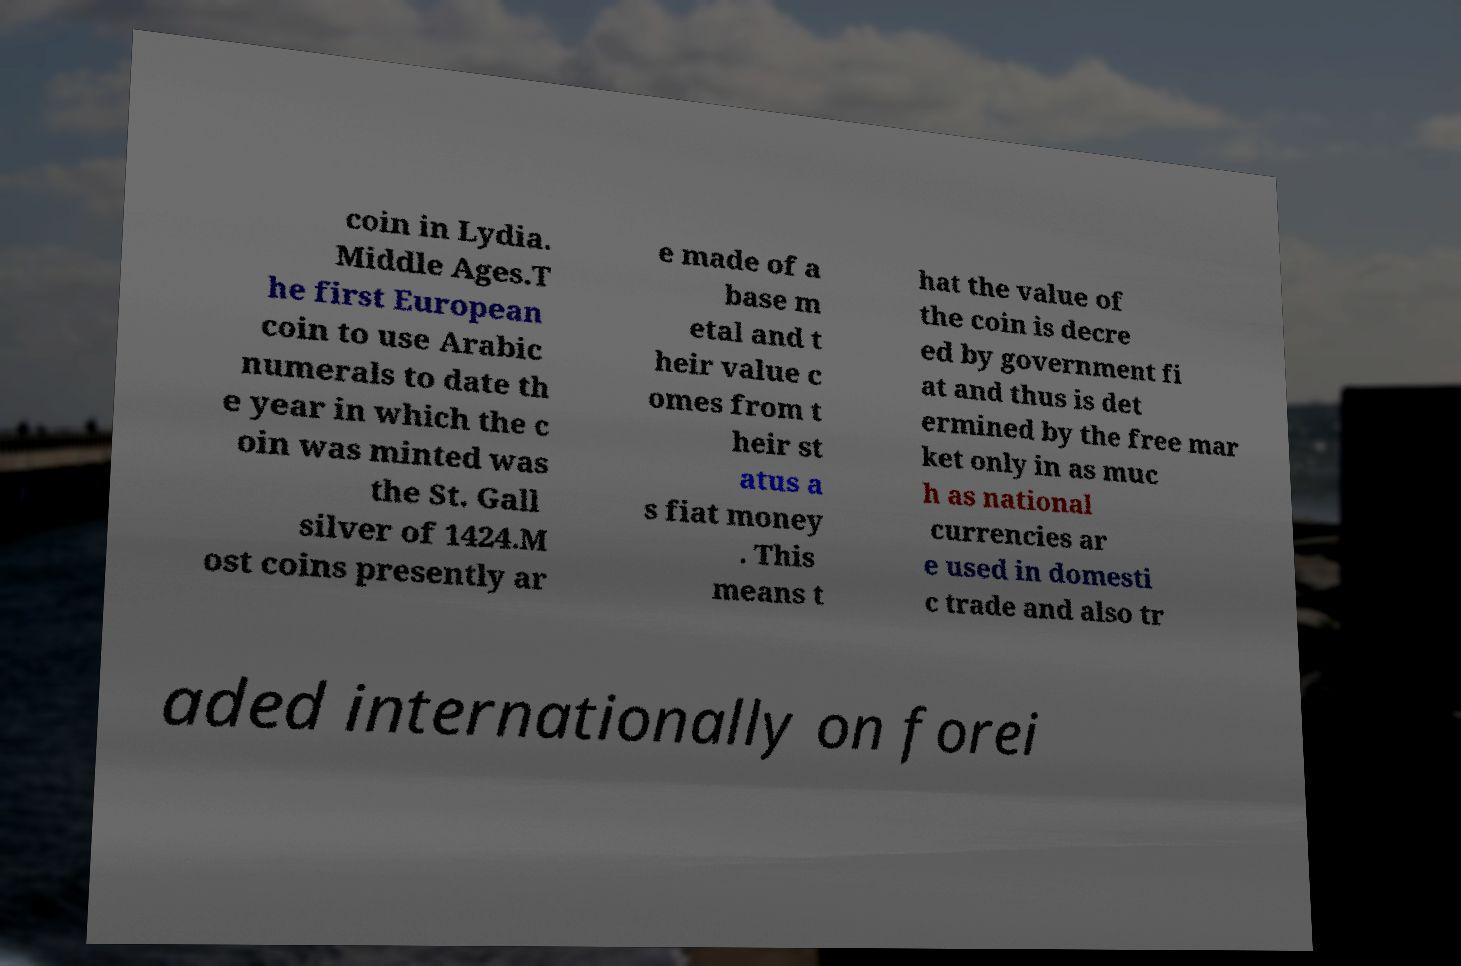Could you assist in decoding the text presented in this image and type it out clearly? coin in Lydia. Middle Ages.T he first European coin to use Arabic numerals to date th e year in which the c oin was minted was the St. Gall silver of 1424.M ost coins presently ar e made of a base m etal and t heir value c omes from t heir st atus a s fiat money . This means t hat the value of the coin is decre ed by government fi at and thus is det ermined by the free mar ket only in as muc h as national currencies ar e used in domesti c trade and also tr aded internationally on forei 